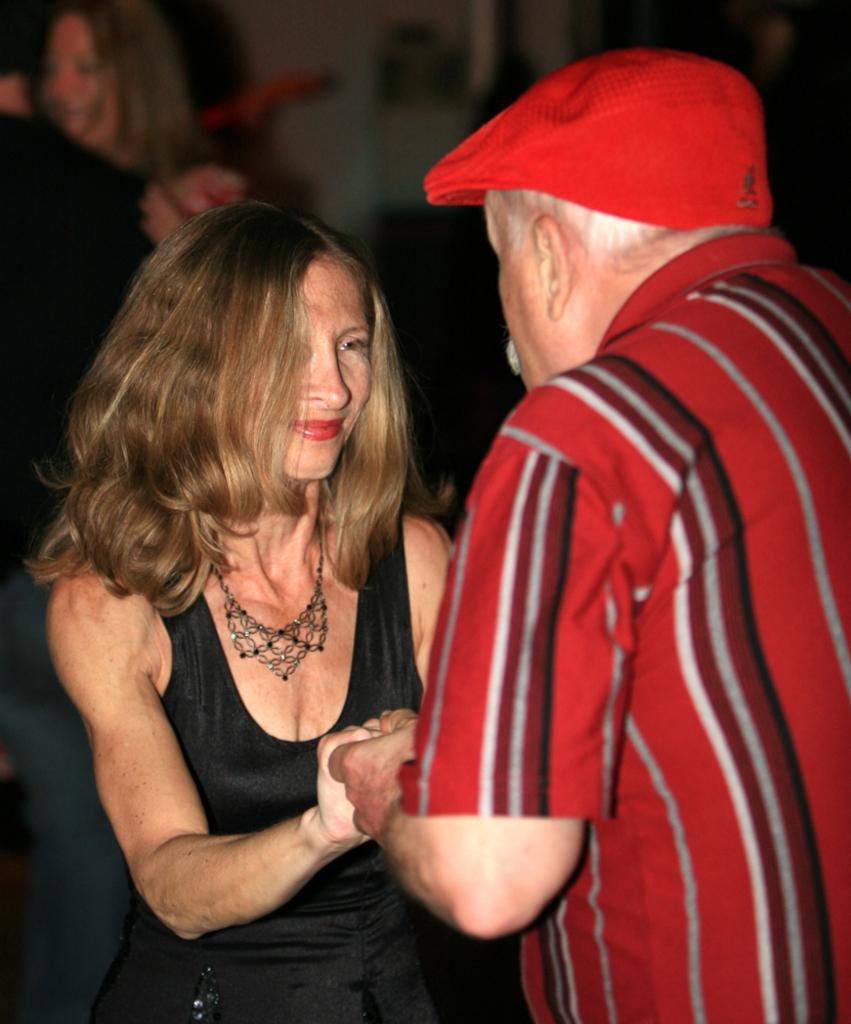Please provide a concise description of this image. In the picture there is a man and woman,they both are holding their hands and looking at each other. 